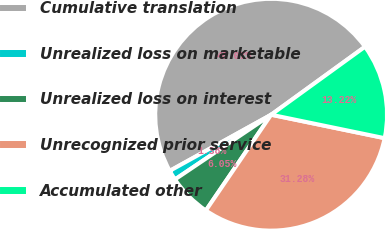Convert chart. <chart><loc_0><loc_0><loc_500><loc_500><pie_chart><fcel>Cumulative translation<fcel>Unrealized loss on marketable<fcel>Unrealized loss on interest<fcel>Unrecognized prior service<fcel>Accumulated other<nl><fcel>48.07%<fcel>1.38%<fcel>6.05%<fcel>31.28%<fcel>13.22%<nl></chart> 